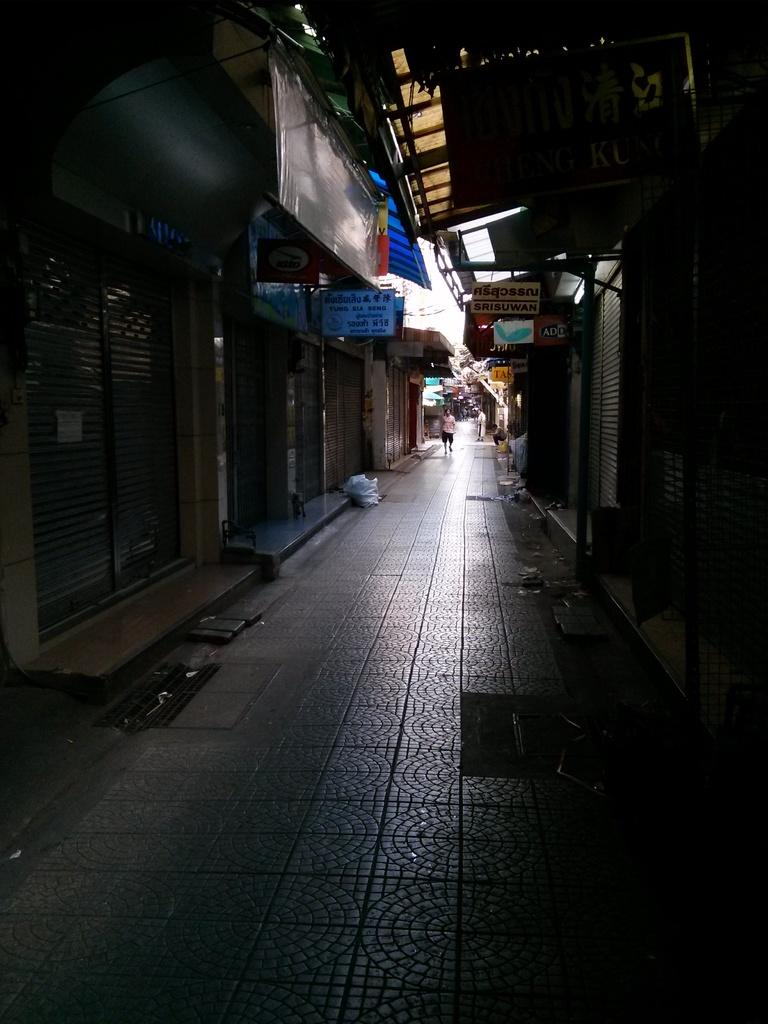What is the main feature of the image? There is a road in the image. What can be seen near the road? There are buildings near the road. Is there any human presence in the image? Yes, there is a person walking in the middle of the image. What type of soup is being served in the scene? There is no soup present in the image, as it features a road, buildings, and a person walking. 